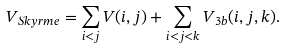Convert formula to latex. <formula><loc_0><loc_0><loc_500><loc_500>V _ { S k y r m e } = \sum _ { i < j } V ( i , j ) + \sum _ { i < j < k } V _ { 3 b } ( i , j , k ) .</formula> 